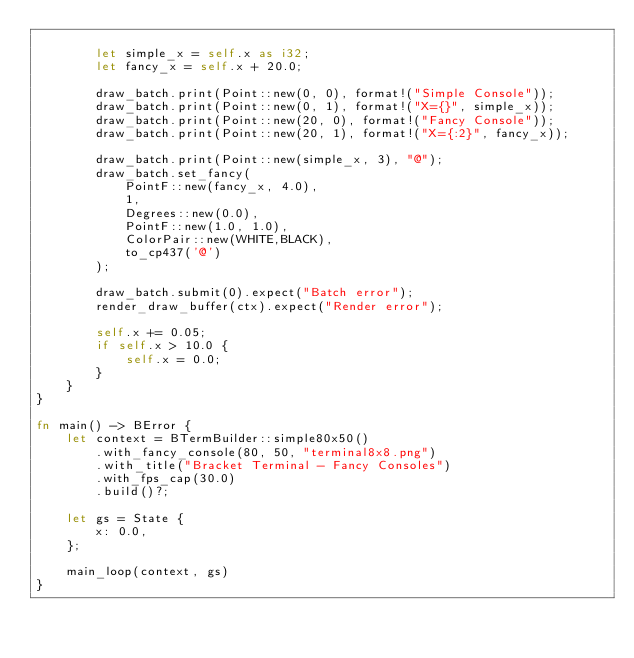Convert code to text. <code><loc_0><loc_0><loc_500><loc_500><_Rust_>
        let simple_x = self.x as i32;
        let fancy_x = self.x + 20.0;

        draw_batch.print(Point::new(0, 0), format!("Simple Console"));
        draw_batch.print(Point::new(0, 1), format!("X={}", simple_x));
        draw_batch.print(Point::new(20, 0), format!("Fancy Console"));
        draw_batch.print(Point::new(20, 1), format!("X={:2}", fancy_x));

        draw_batch.print(Point::new(simple_x, 3), "@");
        draw_batch.set_fancy(
            PointF::new(fancy_x, 4.0),
            1,
            Degrees::new(0.0),
            PointF::new(1.0, 1.0),
            ColorPair::new(WHITE,BLACK),
            to_cp437('@')
        );

        draw_batch.submit(0).expect("Batch error");
        render_draw_buffer(ctx).expect("Render error");

        self.x += 0.05;
        if self.x > 10.0 {
            self.x = 0.0;
        }
    }
}

fn main() -> BError {
    let context = BTermBuilder::simple80x50()
        .with_fancy_console(80, 50, "terminal8x8.png")
        .with_title("Bracket Terminal - Fancy Consoles")
        .with_fps_cap(30.0)
        .build()?;

    let gs = State {
        x: 0.0,
    };

    main_loop(context, gs)
}
</code> 